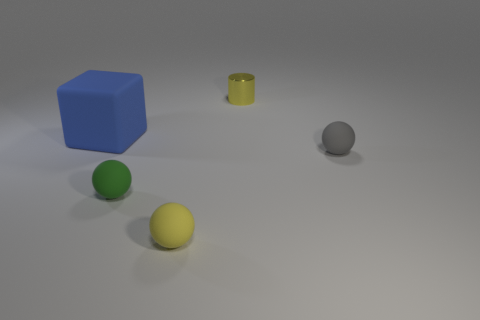Add 1 tiny green balls. How many objects exist? 6 Subtract all cylinders. How many objects are left? 4 Add 1 yellow cubes. How many yellow cubes exist? 1 Subtract 0 brown cubes. How many objects are left? 5 Subtract all big matte things. Subtract all large matte blocks. How many objects are left? 3 Add 3 yellow spheres. How many yellow spheres are left? 4 